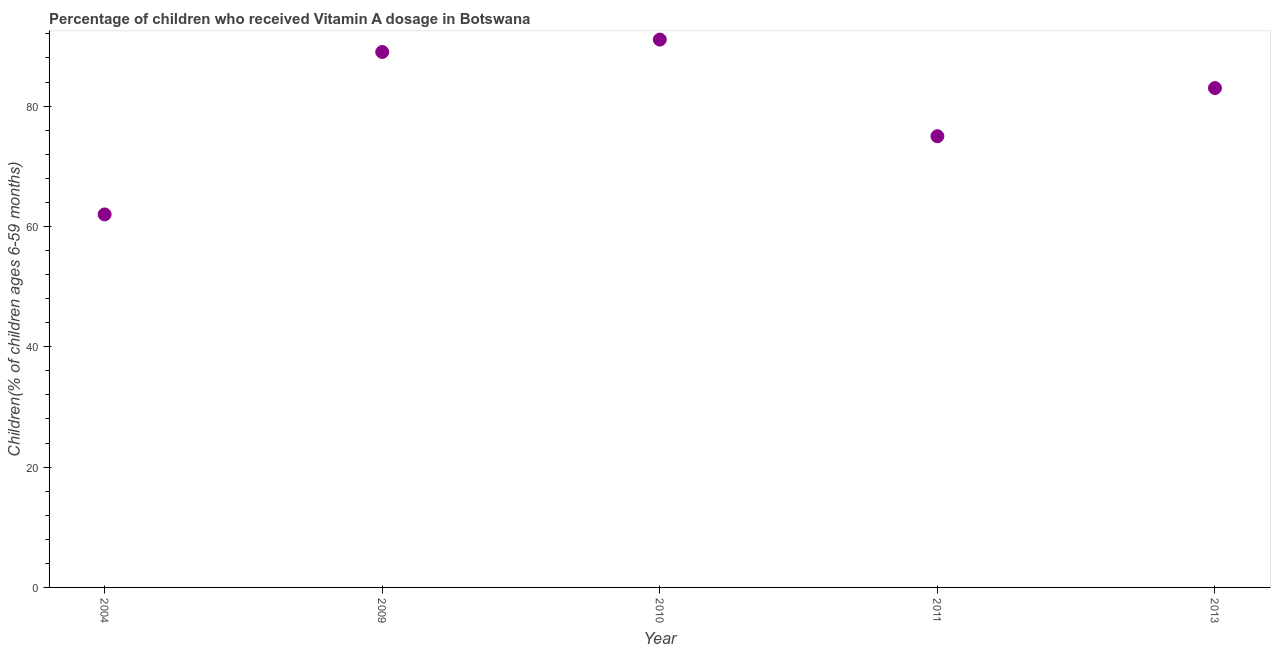What is the vitamin a supplementation coverage rate in 2009?
Offer a very short reply. 89. Across all years, what is the maximum vitamin a supplementation coverage rate?
Give a very brief answer. 91.06. In which year was the vitamin a supplementation coverage rate maximum?
Your answer should be compact. 2010. In which year was the vitamin a supplementation coverage rate minimum?
Provide a succinct answer. 2004. What is the sum of the vitamin a supplementation coverage rate?
Offer a very short reply. 400.06. What is the difference between the vitamin a supplementation coverage rate in 2004 and 2013?
Make the answer very short. -21. What is the average vitamin a supplementation coverage rate per year?
Offer a very short reply. 80.01. Do a majority of the years between 2009 and 2011 (inclusive) have vitamin a supplementation coverage rate greater than 52 %?
Offer a terse response. Yes. What is the ratio of the vitamin a supplementation coverage rate in 2009 to that in 2013?
Offer a terse response. 1.07. Is the difference between the vitamin a supplementation coverage rate in 2009 and 2010 greater than the difference between any two years?
Provide a short and direct response. No. What is the difference between the highest and the second highest vitamin a supplementation coverage rate?
Your answer should be compact. 2.06. What is the difference between the highest and the lowest vitamin a supplementation coverage rate?
Give a very brief answer. 29.06. Does the vitamin a supplementation coverage rate monotonically increase over the years?
Provide a short and direct response. No. How many years are there in the graph?
Provide a short and direct response. 5. Does the graph contain any zero values?
Your answer should be compact. No. Does the graph contain grids?
Provide a succinct answer. No. What is the title of the graph?
Your answer should be compact. Percentage of children who received Vitamin A dosage in Botswana. What is the label or title of the X-axis?
Your response must be concise. Year. What is the label or title of the Y-axis?
Give a very brief answer. Children(% of children ages 6-59 months). What is the Children(% of children ages 6-59 months) in 2004?
Your answer should be very brief. 62. What is the Children(% of children ages 6-59 months) in 2009?
Give a very brief answer. 89. What is the Children(% of children ages 6-59 months) in 2010?
Offer a terse response. 91.06. What is the Children(% of children ages 6-59 months) in 2013?
Offer a terse response. 83. What is the difference between the Children(% of children ages 6-59 months) in 2004 and 2009?
Keep it short and to the point. -27. What is the difference between the Children(% of children ages 6-59 months) in 2004 and 2010?
Ensure brevity in your answer.  -29.06. What is the difference between the Children(% of children ages 6-59 months) in 2004 and 2011?
Offer a very short reply. -13. What is the difference between the Children(% of children ages 6-59 months) in 2009 and 2010?
Make the answer very short. -2.06. What is the difference between the Children(% of children ages 6-59 months) in 2010 and 2011?
Offer a very short reply. 16.06. What is the difference between the Children(% of children ages 6-59 months) in 2010 and 2013?
Your answer should be very brief. 8.06. What is the ratio of the Children(% of children ages 6-59 months) in 2004 to that in 2009?
Offer a terse response. 0.7. What is the ratio of the Children(% of children ages 6-59 months) in 2004 to that in 2010?
Provide a succinct answer. 0.68. What is the ratio of the Children(% of children ages 6-59 months) in 2004 to that in 2011?
Provide a short and direct response. 0.83. What is the ratio of the Children(% of children ages 6-59 months) in 2004 to that in 2013?
Your response must be concise. 0.75. What is the ratio of the Children(% of children ages 6-59 months) in 2009 to that in 2010?
Give a very brief answer. 0.98. What is the ratio of the Children(% of children ages 6-59 months) in 2009 to that in 2011?
Your answer should be compact. 1.19. What is the ratio of the Children(% of children ages 6-59 months) in 2009 to that in 2013?
Provide a succinct answer. 1.07. What is the ratio of the Children(% of children ages 6-59 months) in 2010 to that in 2011?
Your response must be concise. 1.21. What is the ratio of the Children(% of children ages 6-59 months) in 2010 to that in 2013?
Your answer should be compact. 1.1. What is the ratio of the Children(% of children ages 6-59 months) in 2011 to that in 2013?
Make the answer very short. 0.9. 